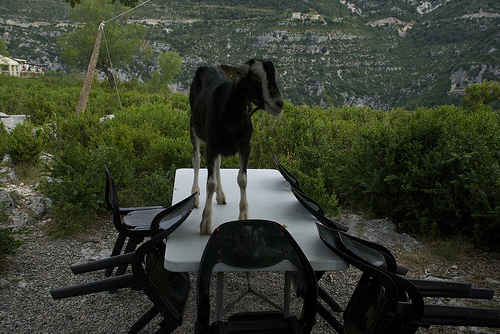<image>
Is the table under the goat? Yes. The table is positioned underneath the goat, with the goat above it in the vertical space. 